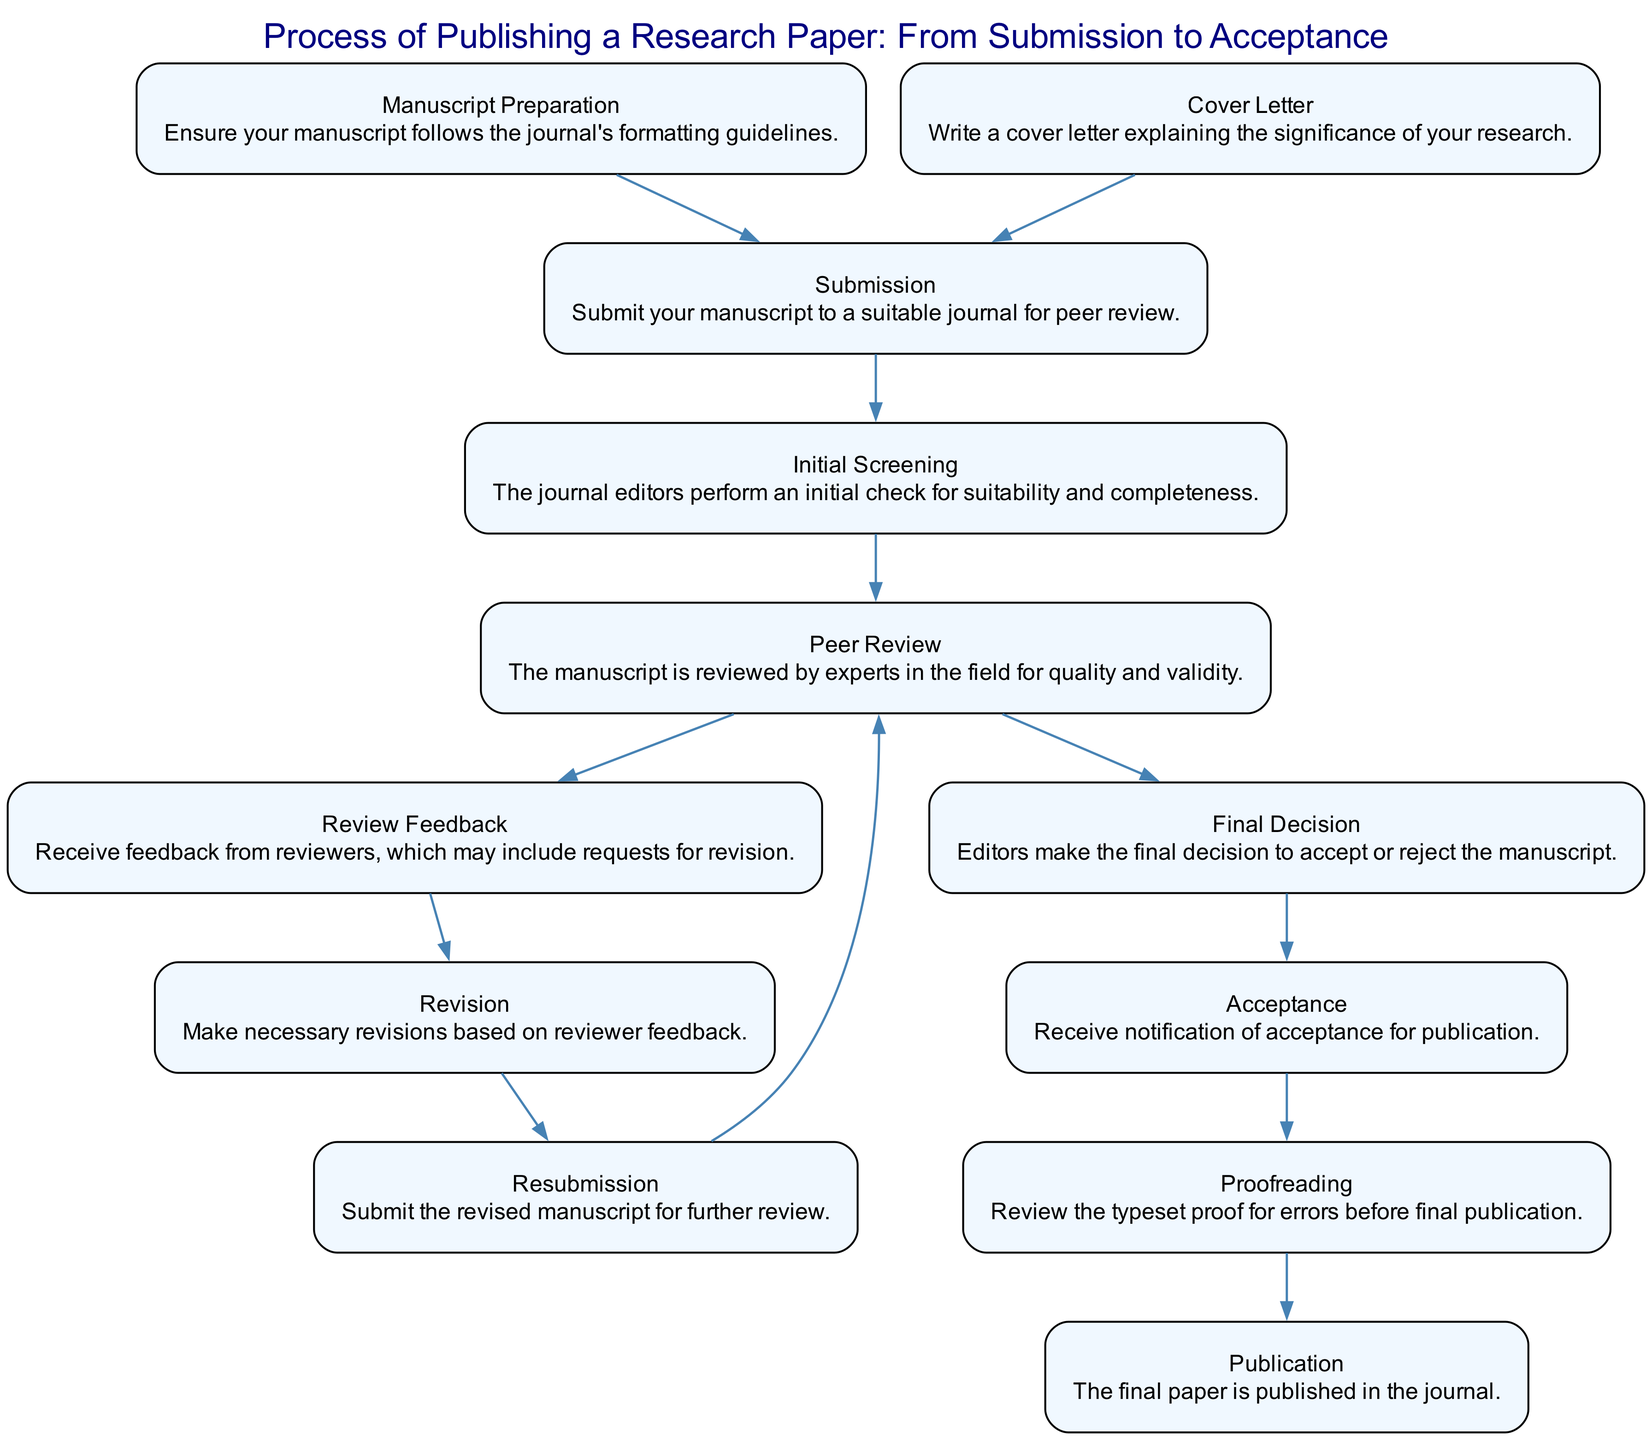What is the first step in the process of publishing a research paper? The first step is indicated as "Submission," where the manuscript is submitted to a suitable journal for peer review.
Answer: Submission How many steps are there in this publishing process? Counting the nodes in the diagram, there are 12 distinct steps outlined in the publishing process.
Answer: 12 What follows after "Peer Review"? After "Peer Review," the next step is "Review Feedback," where reviewers provide their comments and suggestions on the manuscript.
Answer: Review Feedback What is required for "Manuscript Preparation"? "Manuscript Preparation" requires ensuring that the manuscript follows the journal's formatting guidelines before submission.
Answer: Formatting guidelines What happens after the "Final Decision" is made? Once the "Final Decision" is made, if accepted, it leads to the "Acceptance" step, where the author receives notification of publication acceptance.
Answer: Acceptance What is the purpose of the "Cover Letter"? The "Cover Letter" serves to explain the significance of the research being submitted, which is important in the initial submission process.
Answer: Significance of research What step comes after "Revision"? The step that comes after "Revision" is "Resubmission," where the revised manuscript is submitted again for further review.
Answer: Resubmission Which step indicates that the paper is officially published? The step that indicates the paper is officially published is labeled "Publication," which signifies the finalization of the publication process.
Answer: Publication In which sequence are the "Peer Review" and "Final Decision" connected? The sequence shows that "Peer Review" leads to "Review Feedback," then connects to "Final Decision," indicating that decisions are based on peer evaluations.
Answer: Review Feedback to Final Decision 